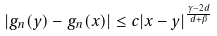<formula> <loc_0><loc_0><loc_500><loc_500>| g _ { n } ( y ) - g _ { n } ( x ) | & \leq c | x - y | ^ { \frac { \gamma - 2 d } { d + \beta } }</formula> 